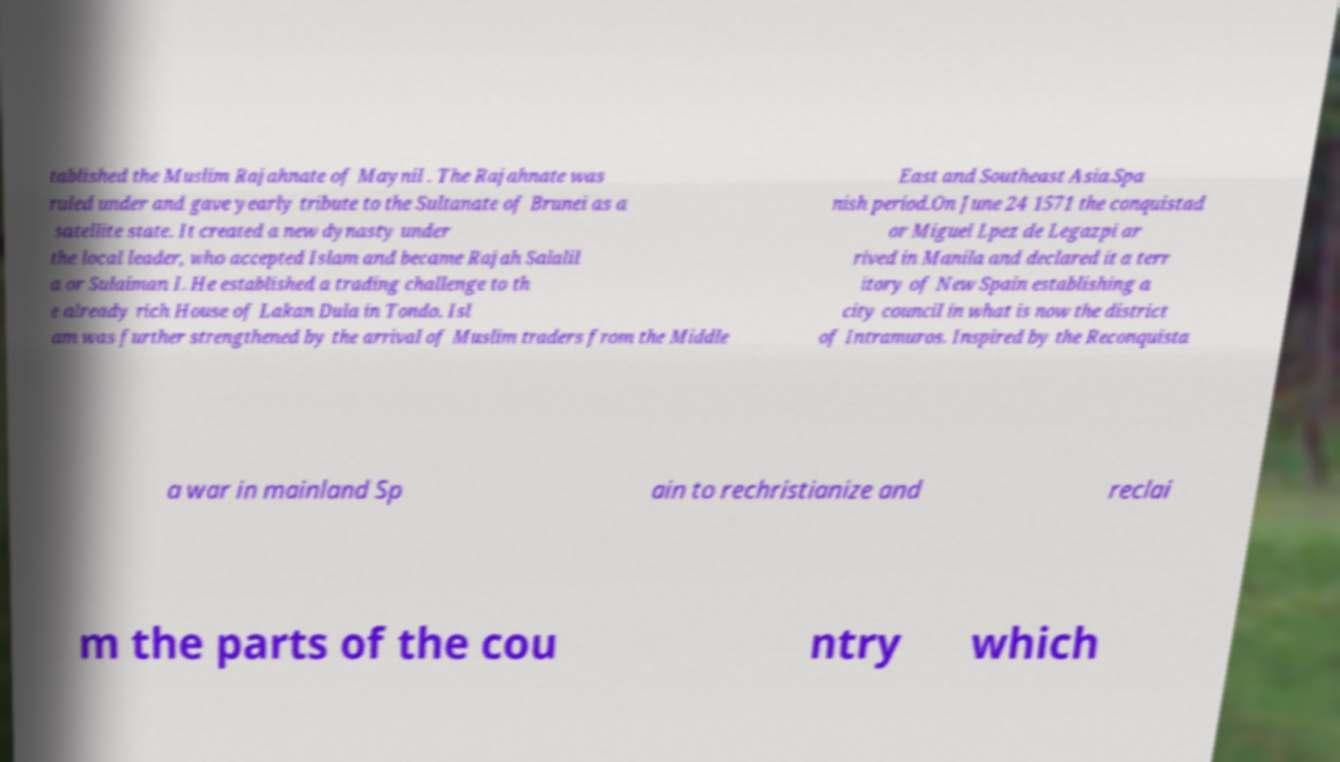Could you assist in decoding the text presented in this image and type it out clearly? tablished the Muslim Rajahnate of Maynil . The Rajahnate was ruled under and gave yearly tribute to the Sultanate of Brunei as a satellite state. It created a new dynasty under the local leader, who accepted Islam and became Rajah Salalil a or Sulaiman I. He established a trading challenge to th e already rich House of Lakan Dula in Tondo. Isl am was further strengthened by the arrival of Muslim traders from the Middle East and Southeast Asia.Spa nish period.On June 24 1571 the conquistad or Miguel Lpez de Legazpi ar rived in Manila and declared it a terr itory of New Spain establishing a city council in what is now the district of Intramuros. Inspired by the Reconquista a war in mainland Sp ain to rechristianize and reclai m the parts of the cou ntry which 